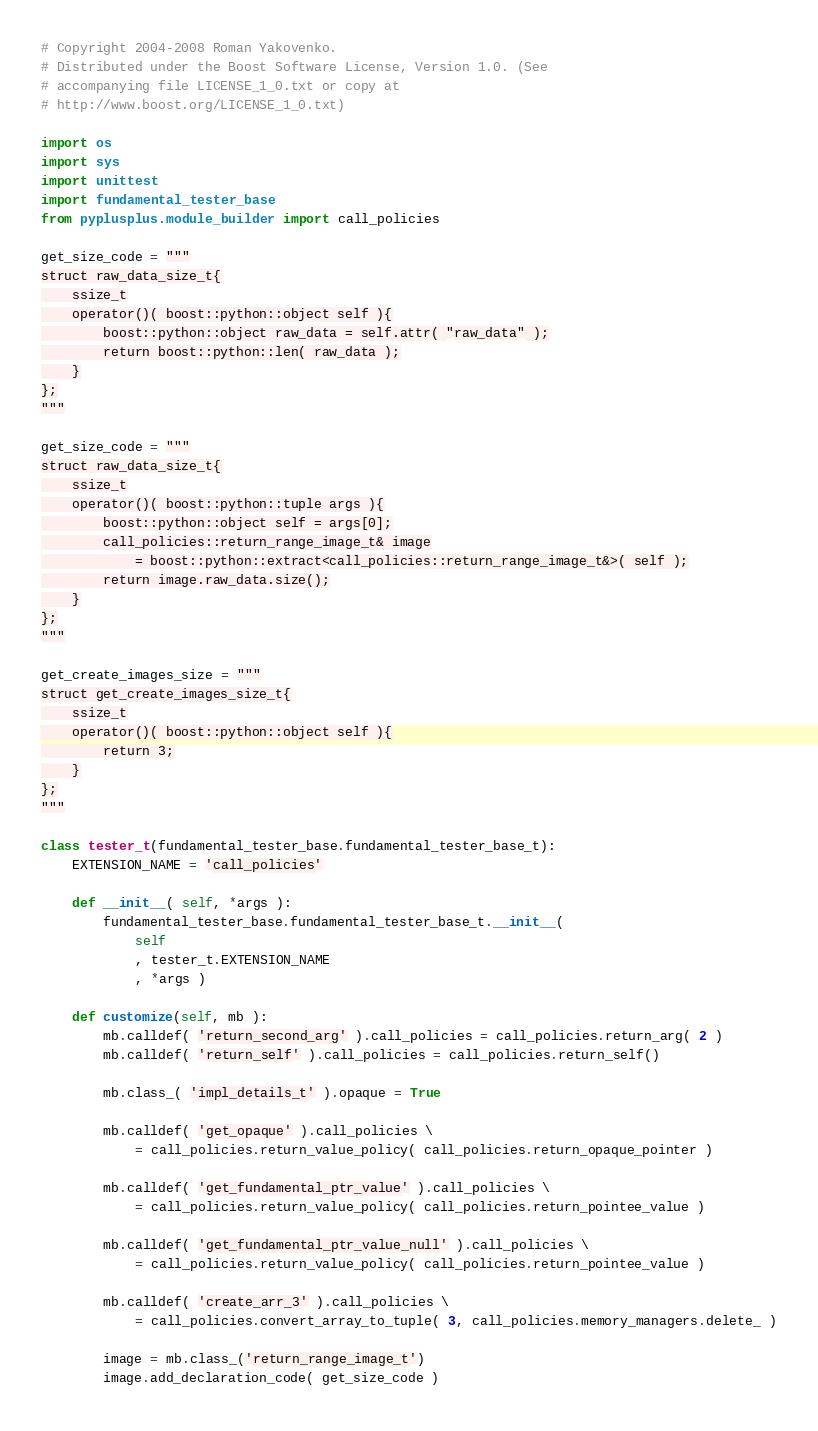Convert code to text. <code><loc_0><loc_0><loc_500><loc_500><_Python_># Copyright 2004-2008 Roman Yakovenko.
# Distributed under the Boost Software License, Version 1.0. (See
# accompanying file LICENSE_1_0.txt or copy at
# http://www.boost.org/LICENSE_1_0.txt)

import os
import sys
import unittest
import fundamental_tester_base
from pyplusplus.module_builder import call_policies

get_size_code = """
struct raw_data_size_t{
    ssize_t
    operator()( boost::python::object self ){
        boost::python::object raw_data = self.attr( "raw_data" );
        return boost::python::len( raw_data );
    }
};
"""

get_size_code = """
struct raw_data_size_t{
    ssize_t
    operator()( boost::python::tuple args ){
        boost::python::object self = args[0];
        call_policies::return_range_image_t& image
            = boost::python::extract<call_policies::return_range_image_t&>( self );
        return image.raw_data.size();
    }
};
"""

get_create_images_size = """
struct get_create_images_size_t{
    ssize_t
    operator()( boost::python::object self ){
        return 3;
    }
};
"""

class tester_t(fundamental_tester_base.fundamental_tester_base_t):
    EXTENSION_NAME = 'call_policies'

    def __init__( self, *args ):
        fundamental_tester_base.fundamental_tester_base_t.__init__(
            self
            , tester_t.EXTENSION_NAME
            , *args )

    def customize(self, mb ):
        mb.calldef( 'return_second_arg' ).call_policies = call_policies.return_arg( 2 )
        mb.calldef( 'return_self' ).call_policies = call_policies.return_self()

        mb.class_( 'impl_details_t' ).opaque = True

        mb.calldef( 'get_opaque' ).call_policies \
            = call_policies.return_value_policy( call_policies.return_opaque_pointer )

        mb.calldef( 'get_fundamental_ptr_value' ).call_policies \
            = call_policies.return_value_policy( call_policies.return_pointee_value )

        mb.calldef( 'get_fundamental_ptr_value_null' ).call_policies \
            = call_policies.return_value_policy( call_policies.return_pointee_value )

        mb.calldef( 'create_arr_3' ).call_policies \
            = call_policies.convert_array_to_tuple( 3, call_policies.memory_managers.delete_ )

        image = mb.class_('return_range_image_t')
        image.add_declaration_code( get_size_code )</code> 